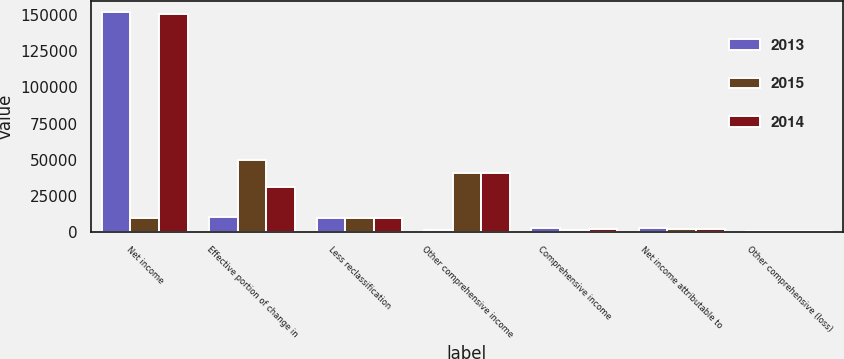Convert chart to OTSL. <chart><loc_0><loc_0><loc_500><loc_500><stacked_bar_chart><ecel><fcel>Net income<fcel>Effective portion of change in<fcel>Less reclassification<fcel>Other comprehensive income<fcel>Comprehensive income<fcel>Net income attributable to<fcel>Other comprehensive (loss)<nl><fcel>2013<fcel>152543<fcel>10089<fcel>9152<fcel>980<fcel>2452<fcel>2487<fcel>35<nl><fcel>2015<fcel>9252.5<fcel>49968<fcel>9353<fcel>40615<fcel>1186<fcel>1457<fcel>271<nl><fcel>2014<fcel>151285<fcel>30985<fcel>9433<fcel>40418<fcel>1588<fcel>1481<fcel>107<nl></chart> 